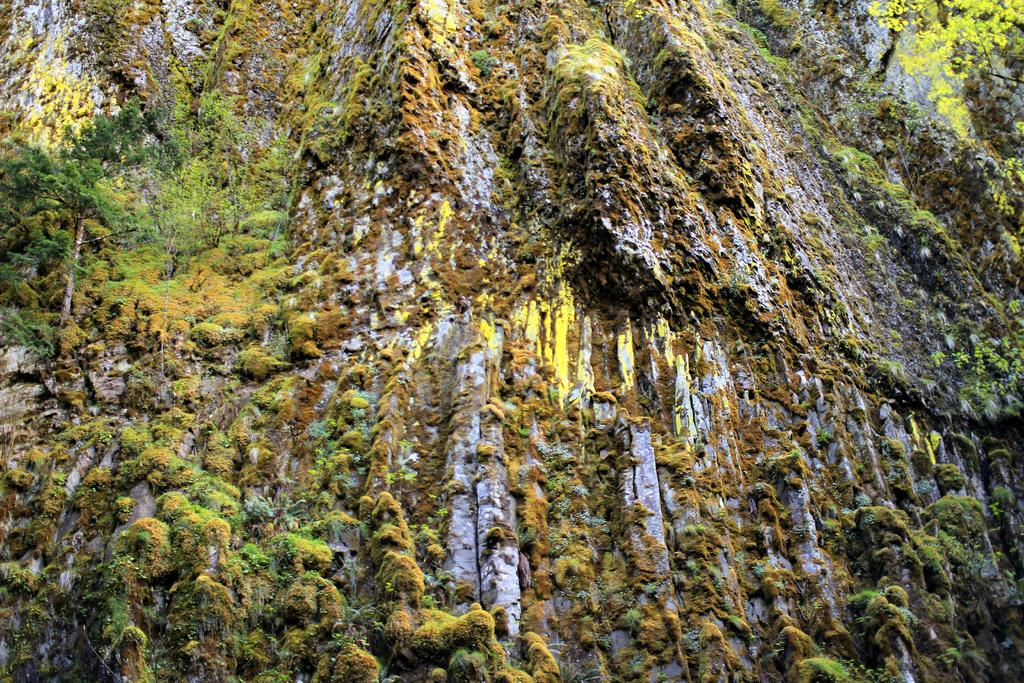What is the main subject of the picture? The main subject of the picture is a mountain. How is the mountain covered? The mountain is covered with trees. What type of net can be seen hanging from the trees on the mountain? There is no net visible in the image; the mountain is covered with trees, but no specific details about the trees or any objects hanging from them are mentioned. 